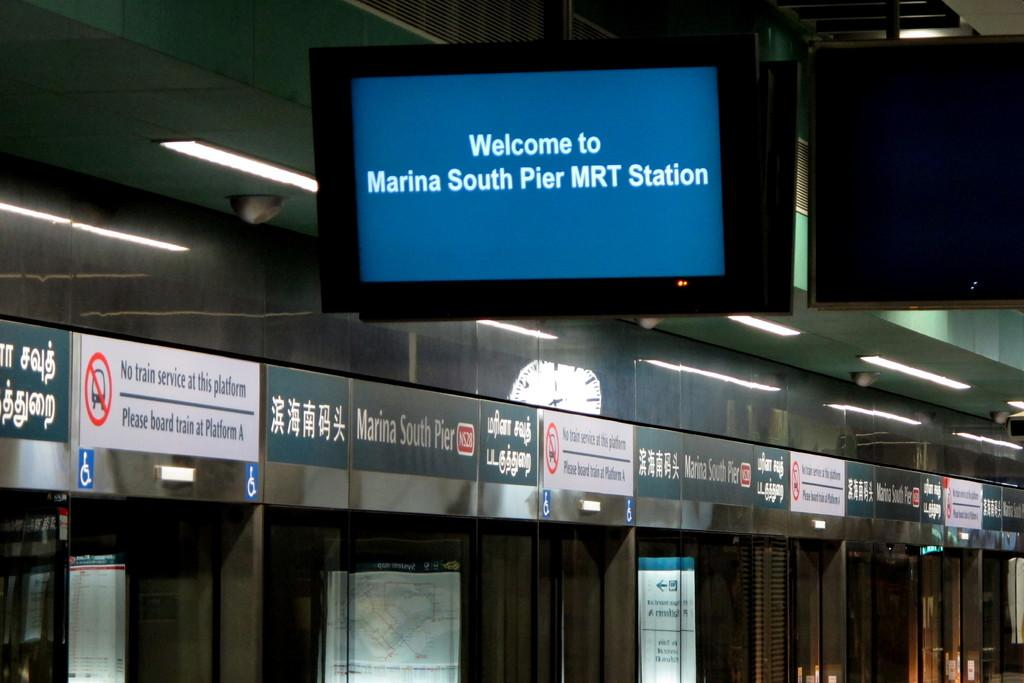<image>
Provide a brief description of the given image. A monitor hung from the ceiling welcomes people to the Marina South Pier MRT Station. 